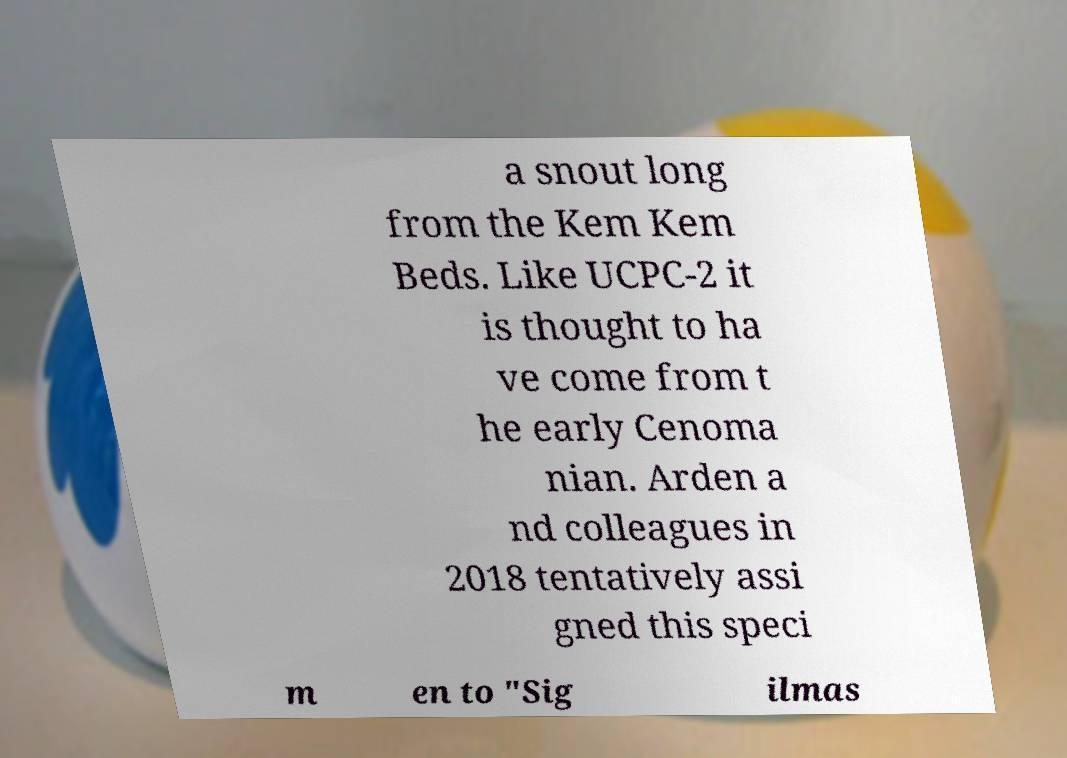Please identify and transcribe the text found in this image. a snout long from the Kem Kem Beds. Like UCPC-2 it is thought to ha ve come from t he early Cenoma nian. Arden a nd colleagues in 2018 tentatively assi gned this speci m en to "Sig ilmas 